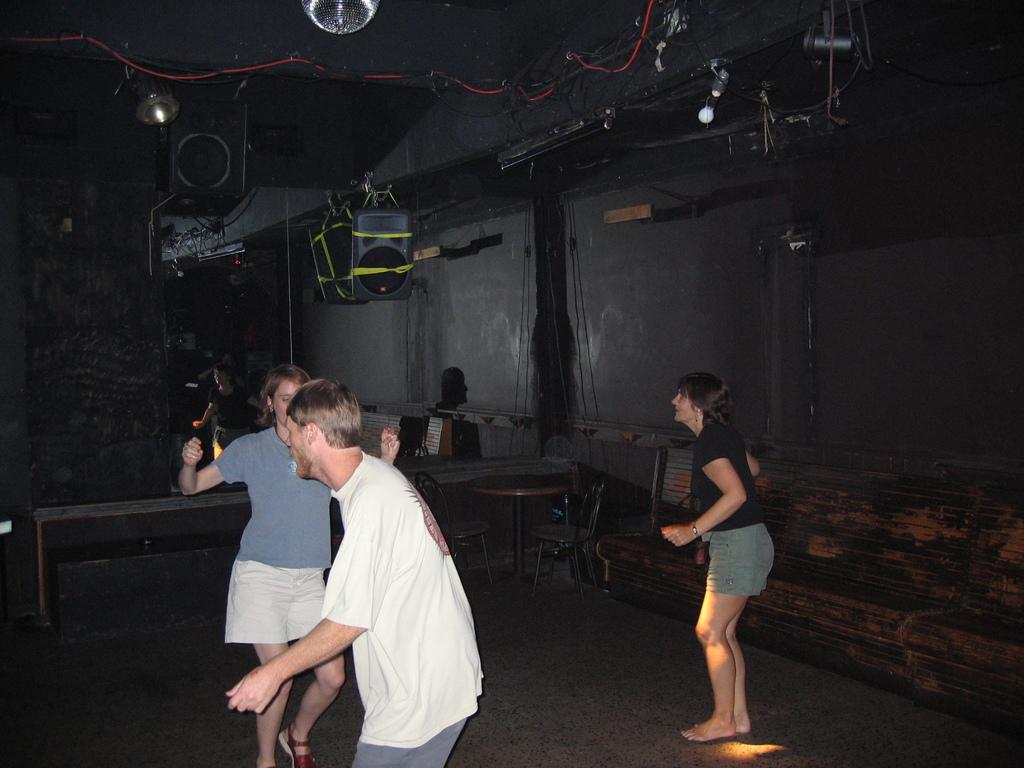Who or what can be seen in the image? There are people in the image. What furniture is present in the image? There is a table and chairs in the image. What can be found on the ceiling in the image? There are bulbs and wires on the ceiling in the image. What type of architectural feature is visible in the image? There is a wall in the image. Can you describe any other objects present in the image? There are other objects in the image, but their specific details are not mentioned in the provided facts. What type of badge is being displayed on the floor in the image? There is no badge present on the floor in the image. 